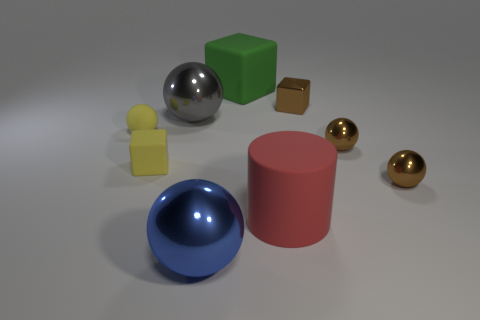There is a tiny cube that is behind the brown shiny sphere that is behind the small matte cube; what is its color?
Offer a very short reply. Brown. What number of balls are either big green things or big shiny things?
Offer a terse response. 2. What number of large cylinders are in front of the small cube on the left side of the cube right of the green rubber block?
Give a very brief answer. 1. The cube that is the same color as the matte sphere is what size?
Make the answer very short. Small. Are there any green cubes that have the same material as the large red thing?
Your answer should be compact. Yes. Do the big red cylinder and the large green block have the same material?
Give a very brief answer. Yes. There is a matte object that is to the right of the large green matte thing; how many large matte objects are to the left of it?
Offer a terse response. 1. What number of green objects are either big rubber things or large cylinders?
Your response must be concise. 1. What shape is the thing that is behind the brown metal object that is behind the big metal ball that is behind the yellow ball?
Your answer should be very brief. Cube. There is a rubber ball that is the same size as the brown shiny block; what color is it?
Provide a short and direct response. Yellow. 